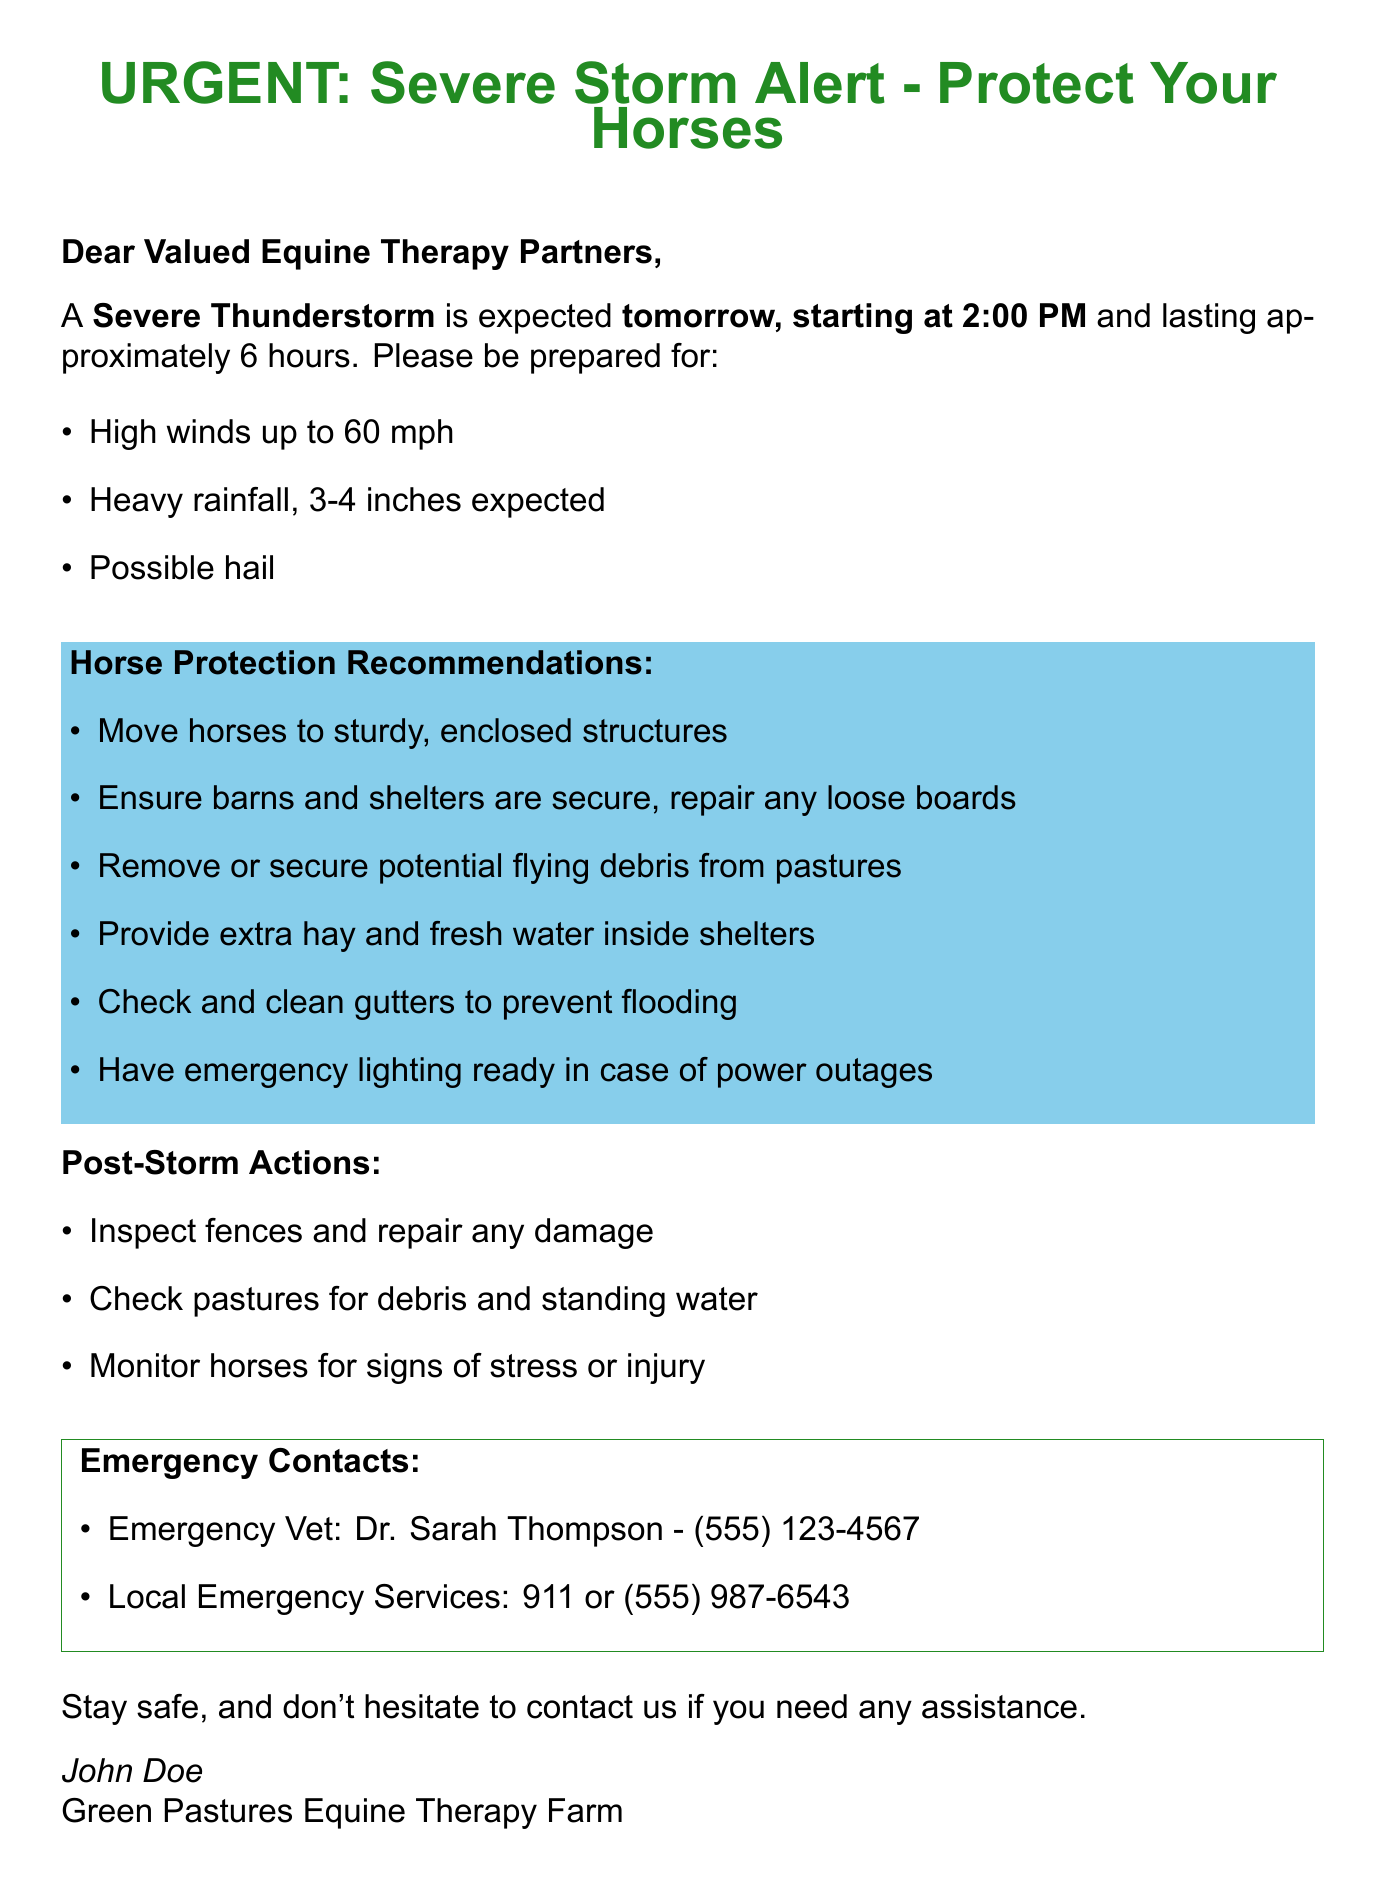What type of storm is predicted? The document states the storm is a Severe Thunderstorm.
Answer: Severe Thunderstorm What time does the storm start? The document specifies that the storm starts tomorrow at 2:00 PM.
Answer: 2:00 PM How long is the storm expected to last? The duration of the storm is mentioned as approximately 6 hours in the document.
Answer: Approximately 6 hours What is the highest wind speed expected? The document lists high winds up to 60 mph as one of the storm's warnings.
Answer: 60 mph What should we do with loose boards in barns? The document advises to repair any loose boards in the shelters.
Answer: Repair any loose boards What contact information is provided for the emergency vet? The document provides contact details for Dr. Sarah Thompson as the emergency vet.
Answer: Dr. Sarah Thompson - (555) 123-4567 Why is it important to remove flying debris? The document suggests securing potential flying debris to protect horses during the storm.
Answer: To protect horses What should be done after the storm regarding pastures? The document states to check pastures for debris and standing water after the storm.
Answer: Check pastures for debris and standing water What is the closing message of the email? The document ends with a message encouraging recipients to stay safe and to contact for assistance.
Answer: Stay safe, and don't hesitate to contact us if you need any assistance 